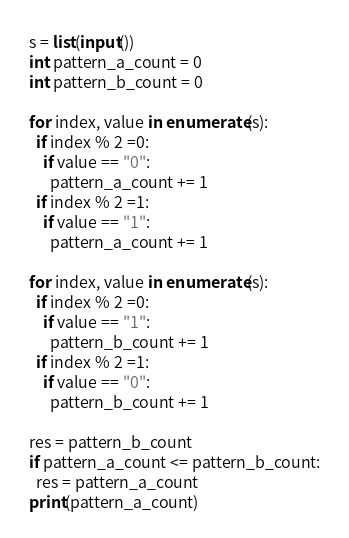<code> <loc_0><loc_0><loc_500><loc_500><_Python_>s = list(input())
int pattern_a_count = 0
int pattern_b_count = 0

for index, value in enumerate(s):
  if index % 2 =0:
    if value == "0":
      pattern_a_count += 1
  if index % 2 =1:
    if value == "1":
      pattern_a_count += 1
      
for index, value in enumerate(s):
  if index % 2 =0:
    if value == "1":
      pattern_b_count += 1
  if index % 2 =1:
    if value == "0":
      pattern_b_count += 1
      
res = pattern_b_count
if pattern_a_count <= pattern_b_count:
  res = pattern_a_count
print(pattern_a_count)</code> 